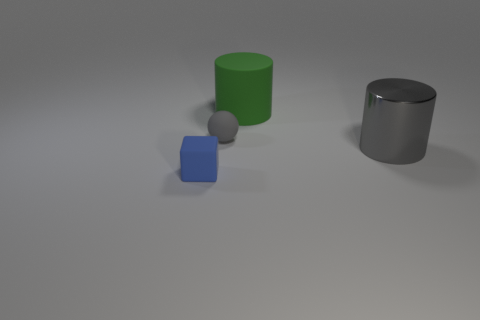Are there any other things that have the same material as the big gray object?
Make the answer very short. No. There is a thing behind the tiny rubber thing that is behind the rubber object on the left side of the tiny gray object; what shape is it?
Your answer should be very brief. Cylinder. How many cylinders have the same material as the small cube?
Give a very brief answer. 1. What number of gray balls are in front of the object that is left of the ball?
Give a very brief answer. 0. There is a cylinder right of the large green rubber cylinder; is its color the same as the small matte object that is behind the big gray metallic thing?
Your answer should be compact. Yes. The matte thing that is both to the left of the green matte thing and behind the large metal cylinder has what shape?
Your answer should be compact. Sphere. Are there any other metallic things that have the same shape as the tiny gray thing?
Your answer should be very brief. No. There is a object that is the same size as the blue block; what is its shape?
Offer a terse response. Sphere. What material is the big green cylinder?
Your answer should be compact. Rubber. How big is the object right of the cylinder that is behind the thing that is right of the large green matte object?
Keep it short and to the point. Large. 